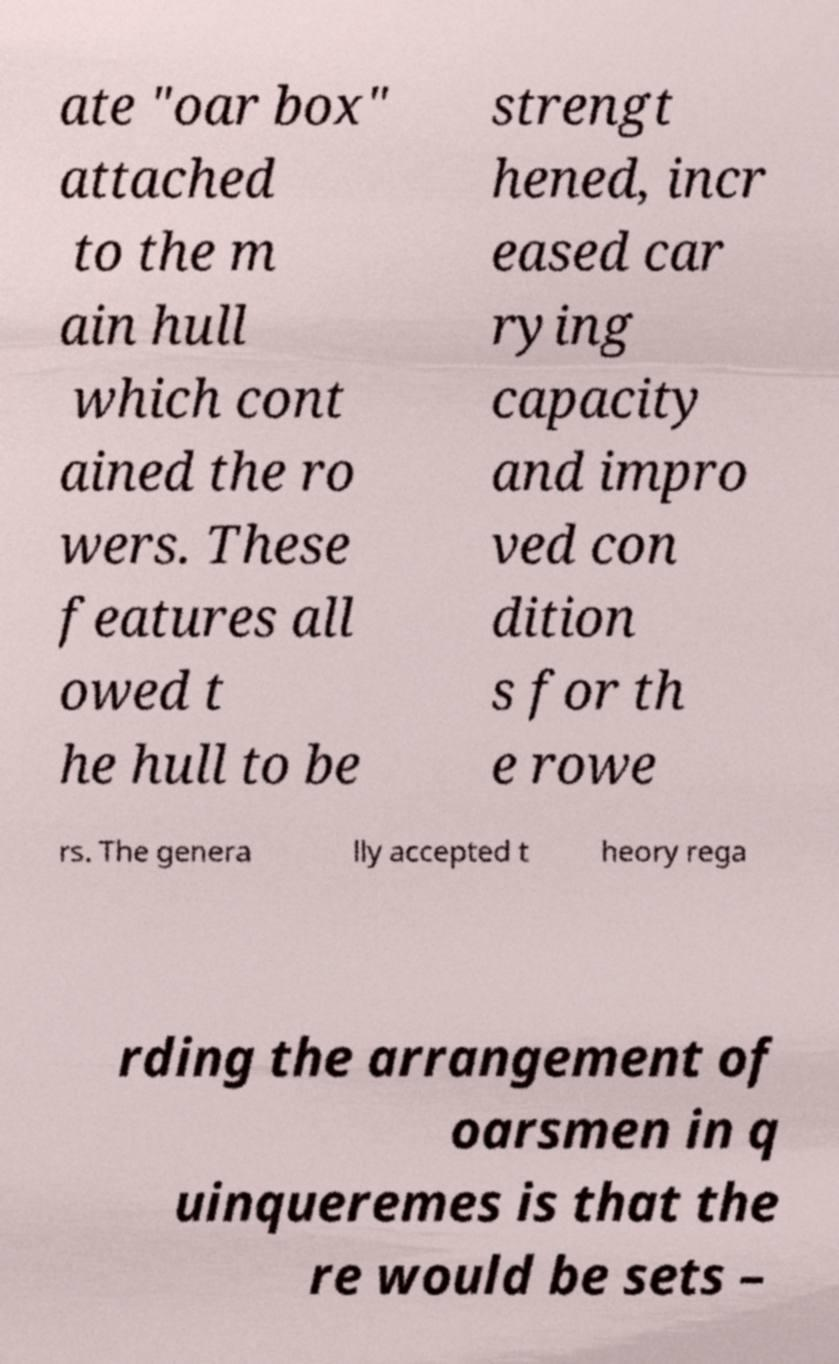Please read and relay the text visible in this image. What does it say? ate "oar box" attached to the m ain hull which cont ained the ro wers. These features all owed t he hull to be strengt hened, incr eased car rying capacity and impro ved con dition s for th e rowe rs. The genera lly accepted t heory rega rding the arrangement of oarsmen in q uinqueremes is that the re would be sets – 